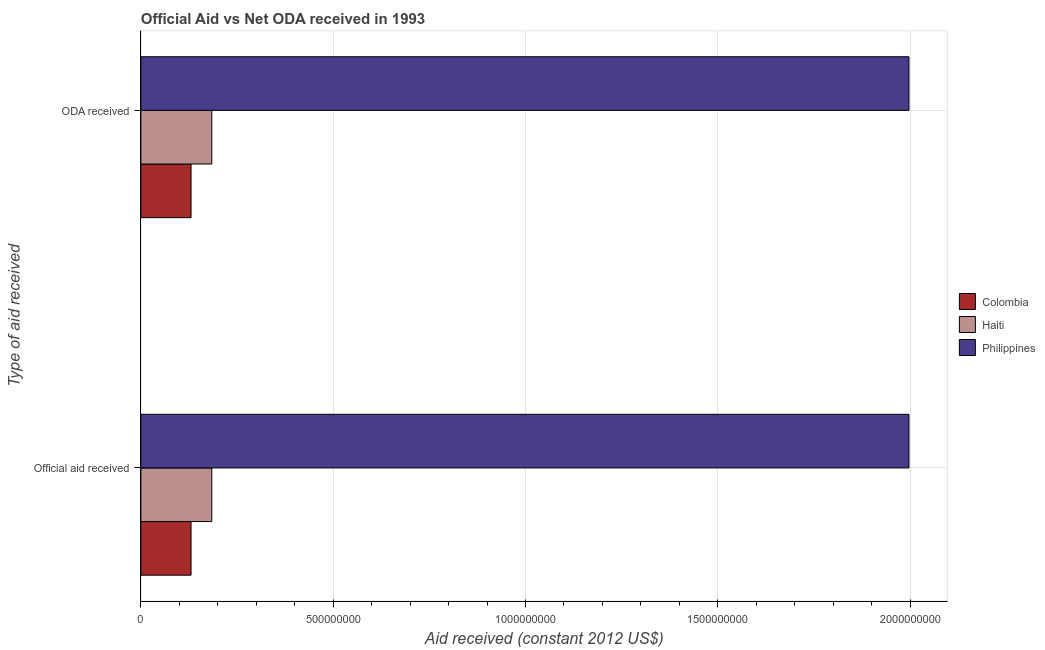How many different coloured bars are there?
Provide a succinct answer. 3. Are the number of bars per tick equal to the number of legend labels?
Ensure brevity in your answer.  Yes. Are the number of bars on each tick of the Y-axis equal?
Provide a short and direct response. Yes. How many bars are there on the 2nd tick from the top?
Your response must be concise. 3. What is the label of the 1st group of bars from the top?
Offer a very short reply. ODA received. What is the oda received in Haiti?
Make the answer very short. 1.84e+08. Across all countries, what is the maximum official aid received?
Your answer should be compact. 2.00e+09. Across all countries, what is the minimum oda received?
Make the answer very short. 1.30e+08. In which country was the official aid received maximum?
Your response must be concise. Philippines. In which country was the official aid received minimum?
Keep it short and to the point. Colombia. What is the total oda received in the graph?
Your answer should be compact. 2.31e+09. What is the difference between the oda received in Haiti and that in Philippines?
Offer a very short reply. -1.81e+09. What is the difference between the oda received in Haiti and the official aid received in Philippines?
Your answer should be very brief. -1.81e+09. What is the average official aid received per country?
Provide a succinct answer. 7.71e+08. What is the difference between the oda received and official aid received in Haiti?
Provide a succinct answer. 0. What is the ratio of the oda received in Haiti to that in Colombia?
Give a very brief answer. 1.41. What does the 3rd bar from the top in Official aid received represents?
Ensure brevity in your answer.  Colombia. What is the difference between two consecutive major ticks on the X-axis?
Your answer should be compact. 5.00e+08. Does the graph contain any zero values?
Offer a terse response. No. Where does the legend appear in the graph?
Offer a very short reply. Center right. How are the legend labels stacked?
Give a very brief answer. Vertical. What is the title of the graph?
Provide a short and direct response. Official Aid vs Net ODA received in 1993 . What is the label or title of the X-axis?
Your answer should be very brief. Aid received (constant 2012 US$). What is the label or title of the Y-axis?
Offer a very short reply. Type of aid received. What is the Aid received (constant 2012 US$) of Colombia in Official aid received?
Ensure brevity in your answer.  1.30e+08. What is the Aid received (constant 2012 US$) in Haiti in Official aid received?
Offer a very short reply. 1.84e+08. What is the Aid received (constant 2012 US$) of Philippines in Official aid received?
Keep it short and to the point. 2.00e+09. What is the Aid received (constant 2012 US$) of Colombia in ODA received?
Provide a short and direct response. 1.30e+08. What is the Aid received (constant 2012 US$) of Haiti in ODA received?
Make the answer very short. 1.84e+08. What is the Aid received (constant 2012 US$) in Philippines in ODA received?
Ensure brevity in your answer.  2.00e+09. Across all Type of aid received, what is the maximum Aid received (constant 2012 US$) of Colombia?
Your answer should be very brief. 1.30e+08. Across all Type of aid received, what is the maximum Aid received (constant 2012 US$) in Haiti?
Provide a short and direct response. 1.84e+08. Across all Type of aid received, what is the maximum Aid received (constant 2012 US$) in Philippines?
Offer a very short reply. 2.00e+09. Across all Type of aid received, what is the minimum Aid received (constant 2012 US$) of Colombia?
Make the answer very short. 1.30e+08. Across all Type of aid received, what is the minimum Aid received (constant 2012 US$) of Haiti?
Your response must be concise. 1.84e+08. Across all Type of aid received, what is the minimum Aid received (constant 2012 US$) of Philippines?
Make the answer very short. 2.00e+09. What is the total Aid received (constant 2012 US$) in Colombia in the graph?
Your response must be concise. 2.61e+08. What is the total Aid received (constant 2012 US$) of Haiti in the graph?
Keep it short and to the point. 3.69e+08. What is the total Aid received (constant 2012 US$) of Philippines in the graph?
Give a very brief answer. 3.99e+09. What is the difference between the Aid received (constant 2012 US$) of Haiti in Official aid received and that in ODA received?
Provide a succinct answer. 0. What is the difference between the Aid received (constant 2012 US$) in Philippines in Official aid received and that in ODA received?
Provide a succinct answer. 0. What is the difference between the Aid received (constant 2012 US$) of Colombia in Official aid received and the Aid received (constant 2012 US$) of Haiti in ODA received?
Your answer should be very brief. -5.40e+07. What is the difference between the Aid received (constant 2012 US$) of Colombia in Official aid received and the Aid received (constant 2012 US$) of Philippines in ODA received?
Your response must be concise. -1.87e+09. What is the difference between the Aid received (constant 2012 US$) in Haiti in Official aid received and the Aid received (constant 2012 US$) in Philippines in ODA received?
Your response must be concise. -1.81e+09. What is the average Aid received (constant 2012 US$) in Colombia per Type of aid received?
Provide a short and direct response. 1.30e+08. What is the average Aid received (constant 2012 US$) of Haiti per Type of aid received?
Provide a short and direct response. 1.84e+08. What is the average Aid received (constant 2012 US$) in Philippines per Type of aid received?
Your response must be concise. 2.00e+09. What is the difference between the Aid received (constant 2012 US$) in Colombia and Aid received (constant 2012 US$) in Haiti in Official aid received?
Keep it short and to the point. -5.40e+07. What is the difference between the Aid received (constant 2012 US$) in Colombia and Aid received (constant 2012 US$) in Philippines in Official aid received?
Keep it short and to the point. -1.87e+09. What is the difference between the Aid received (constant 2012 US$) of Haiti and Aid received (constant 2012 US$) of Philippines in Official aid received?
Your response must be concise. -1.81e+09. What is the difference between the Aid received (constant 2012 US$) of Colombia and Aid received (constant 2012 US$) of Haiti in ODA received?
Your response must be concise. -5.40e+07. What is the difference between the Aid received (constant 2012 US$) of Colombia and Aid received (constant 2012 US$) of Philippines in ODA received?
Give a very brief answer. -1.87e+09. What is the difference between the Aid received (constant 2012 US$) in Haiti and Aid received (constant 2012 US$) in Philippines in ODA received?
Provide a succinct answer. -1.81e+09. What is the ratio of the Aid received (constant 2012 US$) in Colombia in Official aid received to that in ODA received?
Your answer should be compact. 1. What is the ratio of the Aid received (constant 2012 US$) of Haiti in Official aid received to that in ODA received?
Give a very brief answer. 1. What is the ratio of the Aid received (constant 2012 US$) in Philippines in Official aid received to that in ODA received?
Ensure brevity in your answer.  1. What is the difference between the highest and the second highest Aid received (constant 2012 US$) in Colombia?
Make the answer very short. 0. 